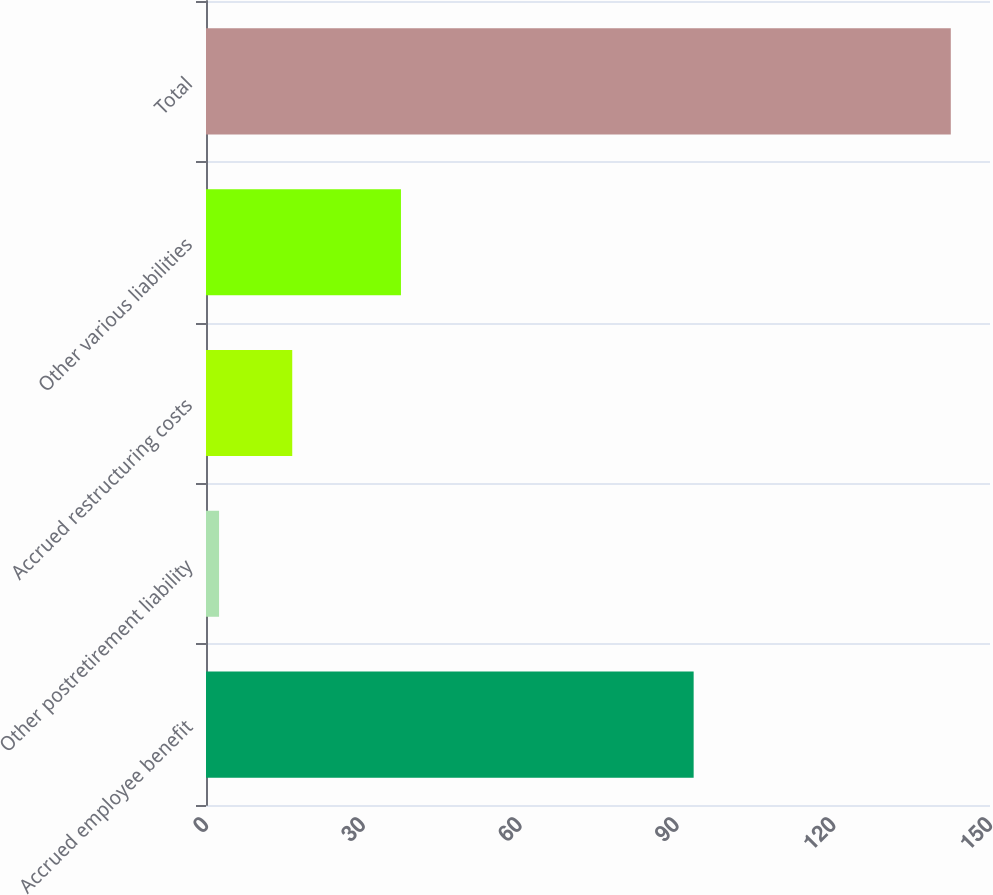<chart> <loc_0><loc_0><loc_500><loc_500><bar_chart><fcel>Accrued employee benefit<fcel>Other postretirement liability<fcel>Accrued restructuring costs<fcel>Other various liabilities<fcel>Total<nl><fcel>93.3<fcel>2.5<fcel>16.5<fcel>37.3<fcel>142.5<nl></chart> 